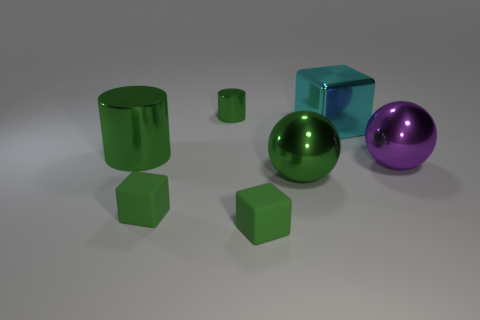There is a large metallic thing that is in front of the large shiny cylinder and to the left of the purple sphere; what is its color?
Give a very brief answer. Green. How many other things are the same size as the purple ball?
Your answer should be compact. 3. There is a purple shiny object; does it have the same size as the green cylinder behind the large cyan block?
Your answer should be very brief. No. What is the color of the block that is the same size as the purple sphere?
Provide a short and direct response. Cyan. The green metal ball has what size?
Your response must be concise. Large. Are the sphere that is right of the large green ball and the large green ball made of the same material?
Your answer should be compact. Yes. Is the cyan object the same shape as the purple metal object?
Provide a succinct answer. No. There is a big metallic object on the left side of the metallic ball left of the large object that is behind the large green shiny cylinder; what is its shape?
Give a very brief answer. Cylinder. There is a small green thing behind the cyan metallic block; is it the same shape as the large green thing on the left side of the small metallic cylinder?
Provide a short and direct response. Yes. Are there any green things that have the same material as the big green ball?
Your answer should be compact. Yes. 